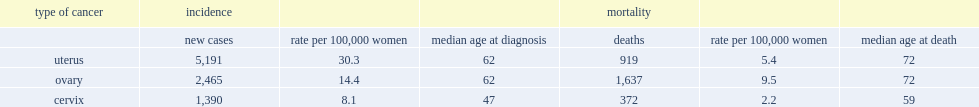What is the incidence rate of uterine cancer in 2010? 30.3. What was the rate of ovarian cancer? 14.4. What was the rate of cervical cancer? 8.1. 